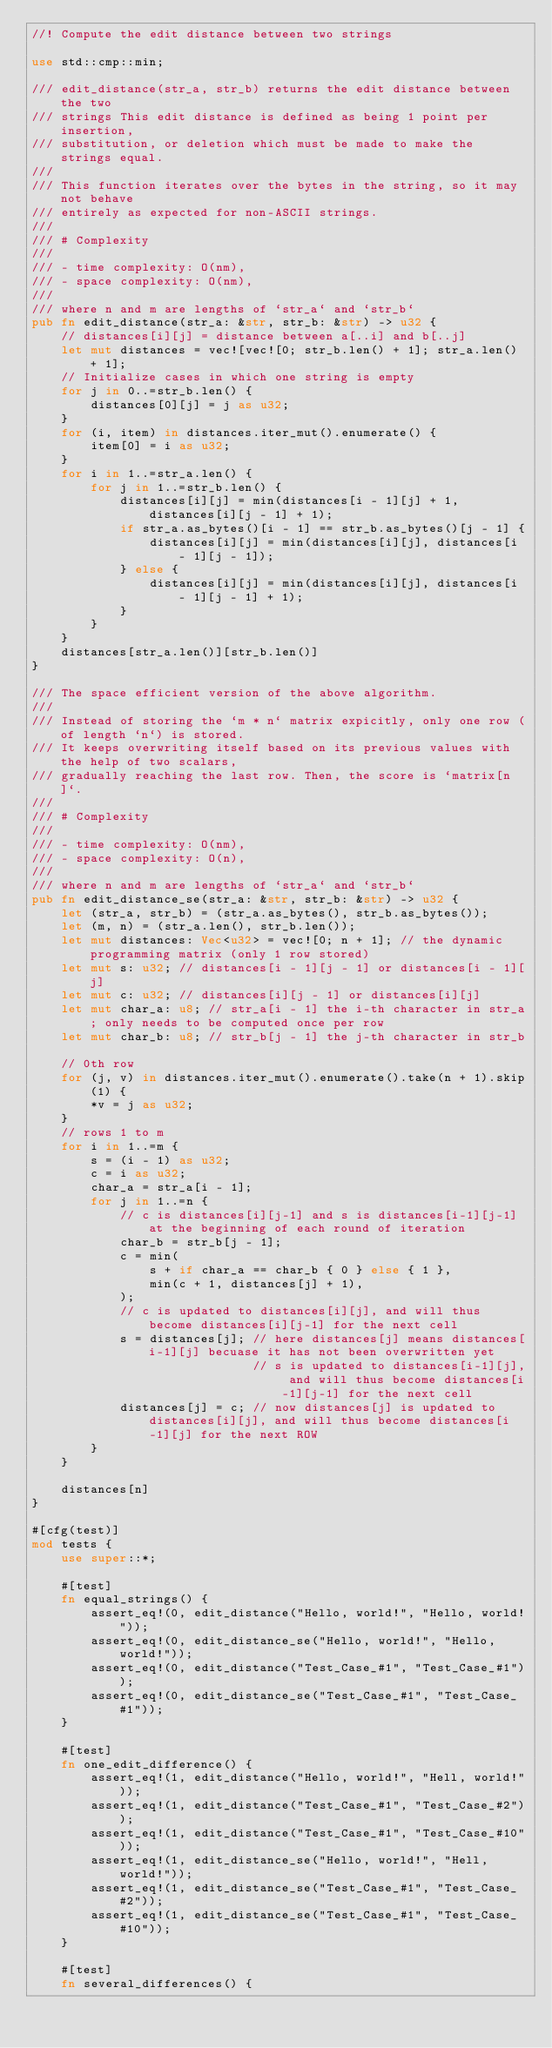<code> <loc_0><loc_0><loc_500><loc_500><_Rust_>//! Compute the edit distance between two strings

use std::cmp::min;

/// edit_distance(str_a, str_b) returns the edit distance between the two
/// strings This edit distance is defined as being 1 point per insertion,
/// substitution, or deletion which must be made to make the strings equal.
///
/// This function iterates over the bytes in the string, so it may not behave
/// entirely as expected for non-ASCII strings.
///
/// # Complexity
///
/// - time complexity: O(nm),
/// - space complexity: O(nm),
///
/// where n and m are lengths of `str_a` and `str_b`
pub fn edit_distance(str_a: &str, str_b: &str) -> u32 {
    // distances[i][j] = distance between a[..i] and b[..j]
    let mut distances = vec![vec![0; str_b.len() + 1]; str_a.len() + 1];
    // Initialize cases in which one string is empty
    for j in 0..=str_b.len() {
        distances[0][j] = j as u32;
    }
    for (i, item) in distances.iter_mut().enumerate() {
        item[0] = i as u32;
    }
    for i in 1..=str_a.len() {
        for j in 1..=str_b.len() {
            distances[i][j] = min(distances[i - 1][j] + 1, distances[i][j - 1] + 1);
            if str_a.as_bytes()[i - 1] == str_b.as_bytes()[j - 1] {
                distances[i][j] = min(distances[i][j], distances[i - 1][j - 1]);
            } else {
                distances[i][j] = min(distances[i][j], distances[i - 1][j - 1] + 1);
            }
        }
    }
    distances[str_a.len()][str_b.len()]
}

/// The space efficient version of the above algorithm.
///
/// Instead of storing the `m * n` matrix expicitly, only one row (of length `n`) is stored.
/// It keeps overwriting itself based on its previous values with the help of two scalars,
/// gradually reaching the last row. Then, the score is `matrix[n]`.
///
/// # Complexity
///
/// - time complexity: O(nm),
/// - space complexity: O(n),
///
/// where n and m are lengths of `str_a` and `str_b`
pub fn edit_distance_se(str_a: &str, str_b: &str) -> u32 {
    let (str_a, str_b) = (str_a.as_bytes(), str_b.as_bytes());
    let (m, n) = (str_a.len(), str_b.len());
    let mut distances: Vec<u32> = vec![0; n + 1]; // the dynamic programming matrix (only 1 row stored)
    let mut s: u32; // distances[i - 1][j - 1] or distances[i - 1][j]
    let mut c: u32; // distances[i][j - 1] or distances[i][j]
    let mut char_a: u8; // str_a[i - 1] the i-th character in str_a; only needs to be computed once per row
    let mut char_b: u8; // str_b[j - 1] the j-th character in str_b

    // 0th row
    for (j, v) in distances.iter_mut().enumerate().take(n + 1).skip(1) {
        *v = j as u32;
    }
    // rows 1 to m
    for i in 1..=m {
        s = (i - 1) as u32;
        c = i as u32;
        char_a = str_a[i - 1];
        for j in 1..=n {
            // c is distances[i][j-1] and s is distances[i-1][j-1] at the beginning of each round of iteration
            char_b = str_b[j - 1];
            c = min(
                s + if char_a == char_b { 0 } else { 1 },
                min(c + 1, distances[j] + 1),
            );
            // c is updated to distances[i][j], and will thus become distances[i][j-1] for the next cell
            s = distances[j]; // here distances[j] means distances[i-1][j] becuase it has not been overwritten yet
                              // s is updated to distances[i-1][j], and will thus become distances[i-1][j-1] for the next cell
            distances[j] = c; // now distances[j] is updated to distances[i][j], and will thus become distances[i-1][j] for the next ROW
        }
    }

    distances[n]
}

#[cfg(test)]
mod tests {
    use super::*;

    #[test]
    fn equal_strings() {
        assert_eq!(0, edit_distance("Hello, world!", "Hello, world!"));
        assert_eq!(0, edit_distance_se("Hello, world!", "Hello, world!"));
        assert_eq!(0, edit_distance("Test_Case_#1", "Test_Case_#1"));
        assert_eq!(0, edit_distance_se("Test_Case_#1", "Test_Case_#1"));
    }

    #[test]
    fn one_edit_difference() {
        assert_eq!(1, edit_distance("Hello, world!", "Hell, world!"));
        assert_eq!(1, edit_distance("Test_Case_#1", "Test_Case_#2"));
        assert_eq!(1, edit_distance("Test_Case_#1", "Test_Case_#10"));
        assert_eq!(1, edit_distance_se("Hello, world!", "Hell, world!"));
        assert_eq!(1, edit_distance_se("Test_Case_#1", "Test_Case_#2"));
        assert_eq!(1, edit_distance_se("Test_Case_#1", "Test_Case_#10"));
    }

    #[test]
    fn several_differences() {</code> 